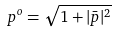<formula> <loc_0><loc_0><loc_500><loc_500>p ^ { o } = \sqrt { 1 + | \bar { p } | ^ { 2 } }</formula> 